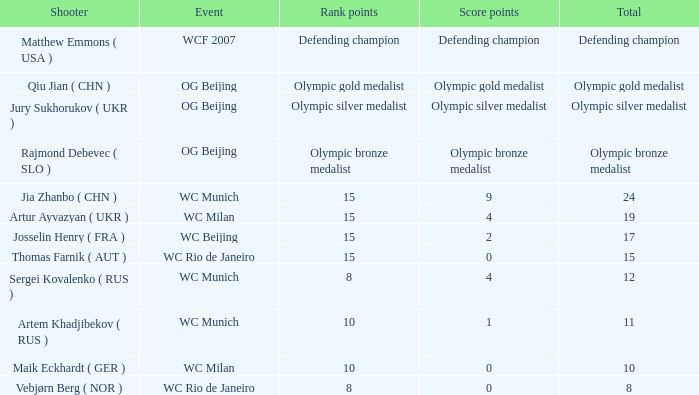What is the sum of score points for an olympic bronze medalist? Olympic bronze medalist. 